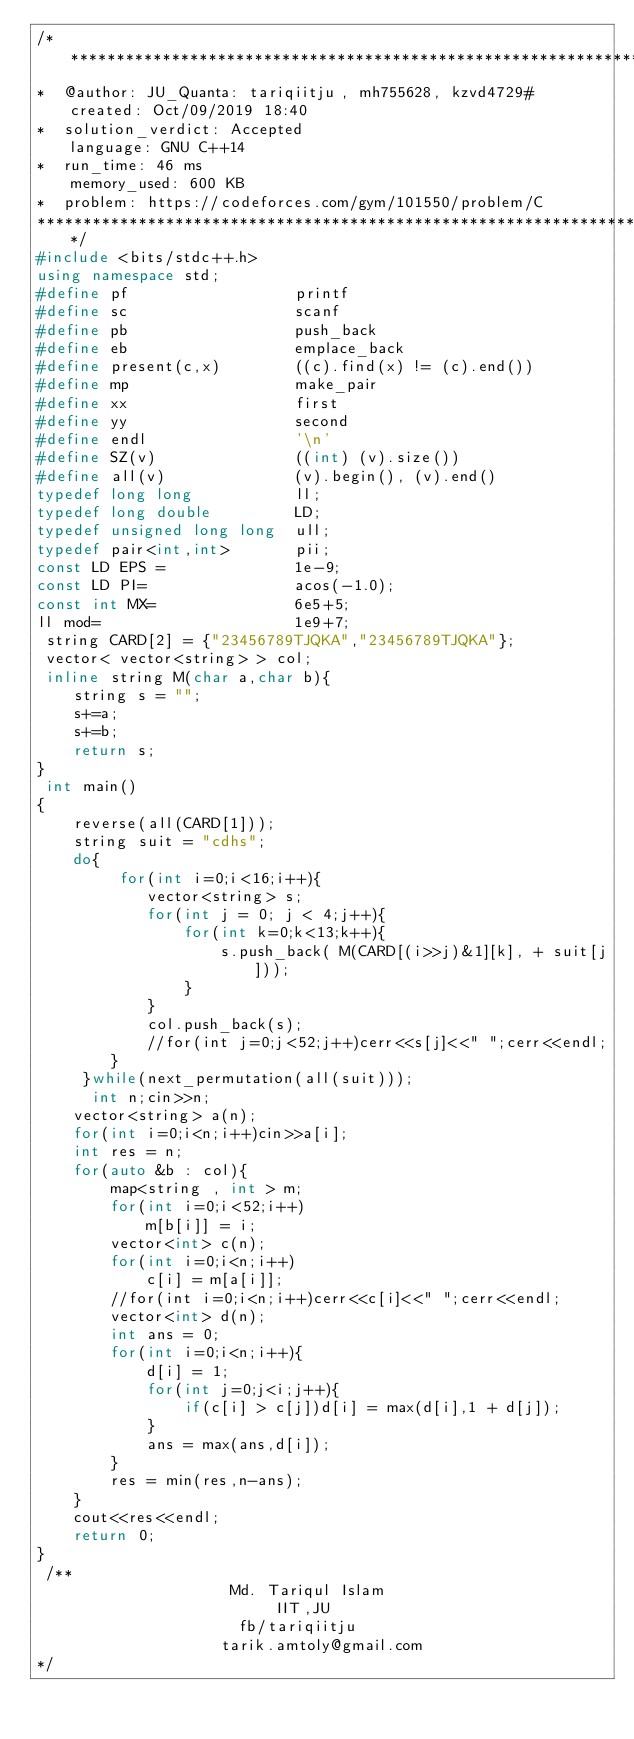Convert code to text. <code><loc_0><loc_0><loc_500><loc_500><_C++_>/****************************************************************************************
*  @author: JU_Quanta: tariqiitju, mh755628, kzvd4729#       created: Oct/09/2019 18:40                        
*  solution_verdict: Accepted                                language: GNU C++14                               
*  run_time: 46 ms                                           memory_used: 600 KB                               
*  problem: https://codeforces.com/gym/101550/problem/C
****************************************************************************************/
#include <bits/stdc++.h>
using namespace std;
#define pf                  printf
#define sc                  scanf
#define pb                  push_back
#define eb                  emplace_back
#define present(c,x)        ((c).find(x) != (c).end())
#define mp                  make_pair
#define xx                  first
#define yy                  second
#define endl                '\n'
#define SZ(v)               ((int) (v).size())
#define all(v)              (v).begin(), (v).end()
typedef long long           ll;
typedef long double         LD;
typedef unsigned long long  ull;
typedef pair<int,int>       pii;
const LD EPS =              1e-9;
const LD PI=                acos(-1.0);
const int MX=               6e5+5;
ll mod=                     1e9+7;
 string CARD[2] = {"23456789TJQKA","23456789TJQKA"};
 vector< vector<string> > col;
 inline string M(char a,char b){
    string s = "";
    s+=a;
    s+=b;
    return s;
}
 int main()
{
    reverse(all(CARD[1]));
    string suit = "cdhs";
    do{
         for(int i=0;i<16;i++){
            vector<string> s;
            for(int j = 0; j < 4;j++){
                for(int k=0;k<13;k++){
                    s.push_back( M(CARD[(i>>j)&1][k], + suit[j]));
                }
            }
            col.push_back(s);
            //for(int j=0;j<52;j++)cerr<<s[j]<<" ";cerr<<endl;
        }
     }while(next_permutation(all(suit)));
      int n;cin>>n;
    vector<string> a(n);
    for(int i=0;i<n;i++)cin>>a[i];
    int res = n;
    for(auto &b : col){
        map<string , int > m;
        for(int i=0;i<52;i++)
            m[b[i]] = i;
        vector<int> c(n);
        for(int i=0;i<n;i++)
            c[i] = m[a[i]];
        //for(int i=0;i<n;i++)cerr<<c[i]<<" ";cerr<<endl;
        vector<int> d(n);
        int ans = 0;
        for(int i=0;i<n;i++){
            d[i] = 1;
            for(int j=0;j<i;j++){
                if(c[i] > c[j])d[i] = max(d[i],1 + d[j]);
            }
            ans = max(ans,d[i]);
        }
        res = min(res,n-ans);
    }
    cout<<res<<endl;
    return 0;
}
 /**
                     Md. Tariqul Islam
                          IIT,JU
                      fb/tariqiitju
                    tarik.amtoly@gmail.com
*/</code> 